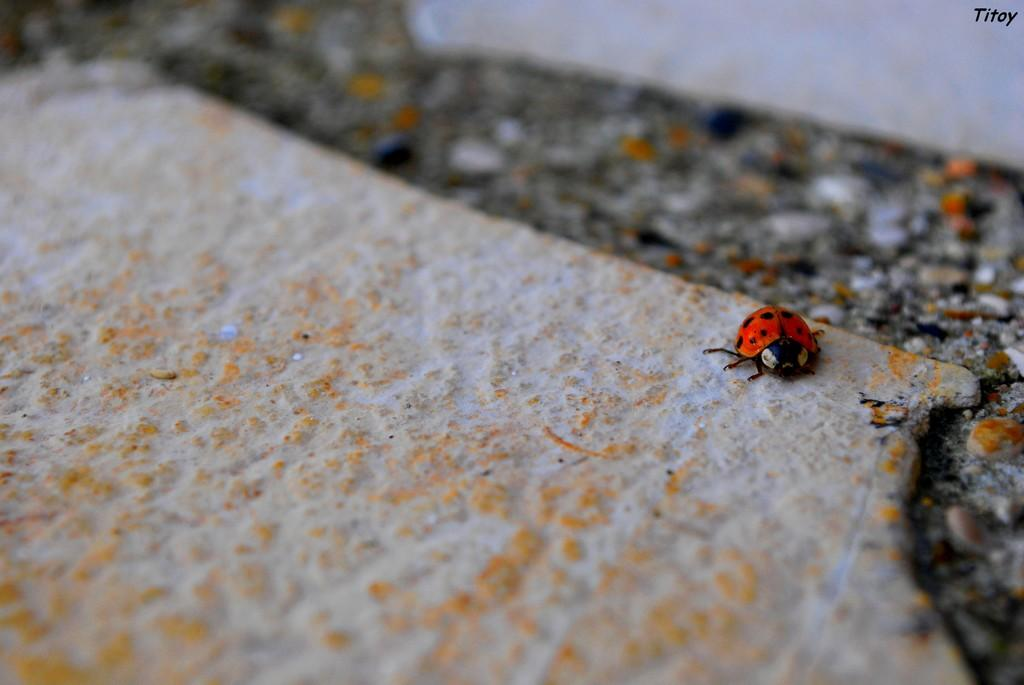What type of creature is present in the image? There is an insect in the image. Where is the insect located in the image? The insect is on a surface. What type of celery is the insect using to communicate with the wax in the image? There is no celery or wax present in the image, and the insect is not communicating with any celery or wax. 